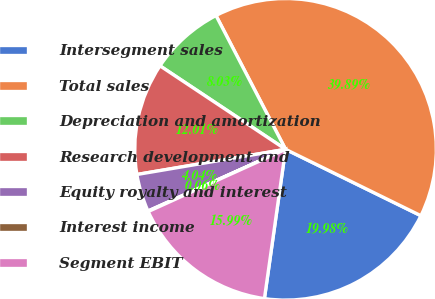Convert chart. <chart><loc_0><loc_0><loc_500><loc_500><pie_chart><fcel>Intersegment sales<fcel>Total sales<fcel>Depreciation and amortization<fcel>Research development and<fcel>Equity royalty and interest<fcel>Interest income<fcel>Segment EBIT<nl><fcel>19.98%<fcel>39.89%<fcel>8.03%<fcel>12.01%<fcel>4.04%<fcel>0.06%<fcel>15.99%<nl></chart> 